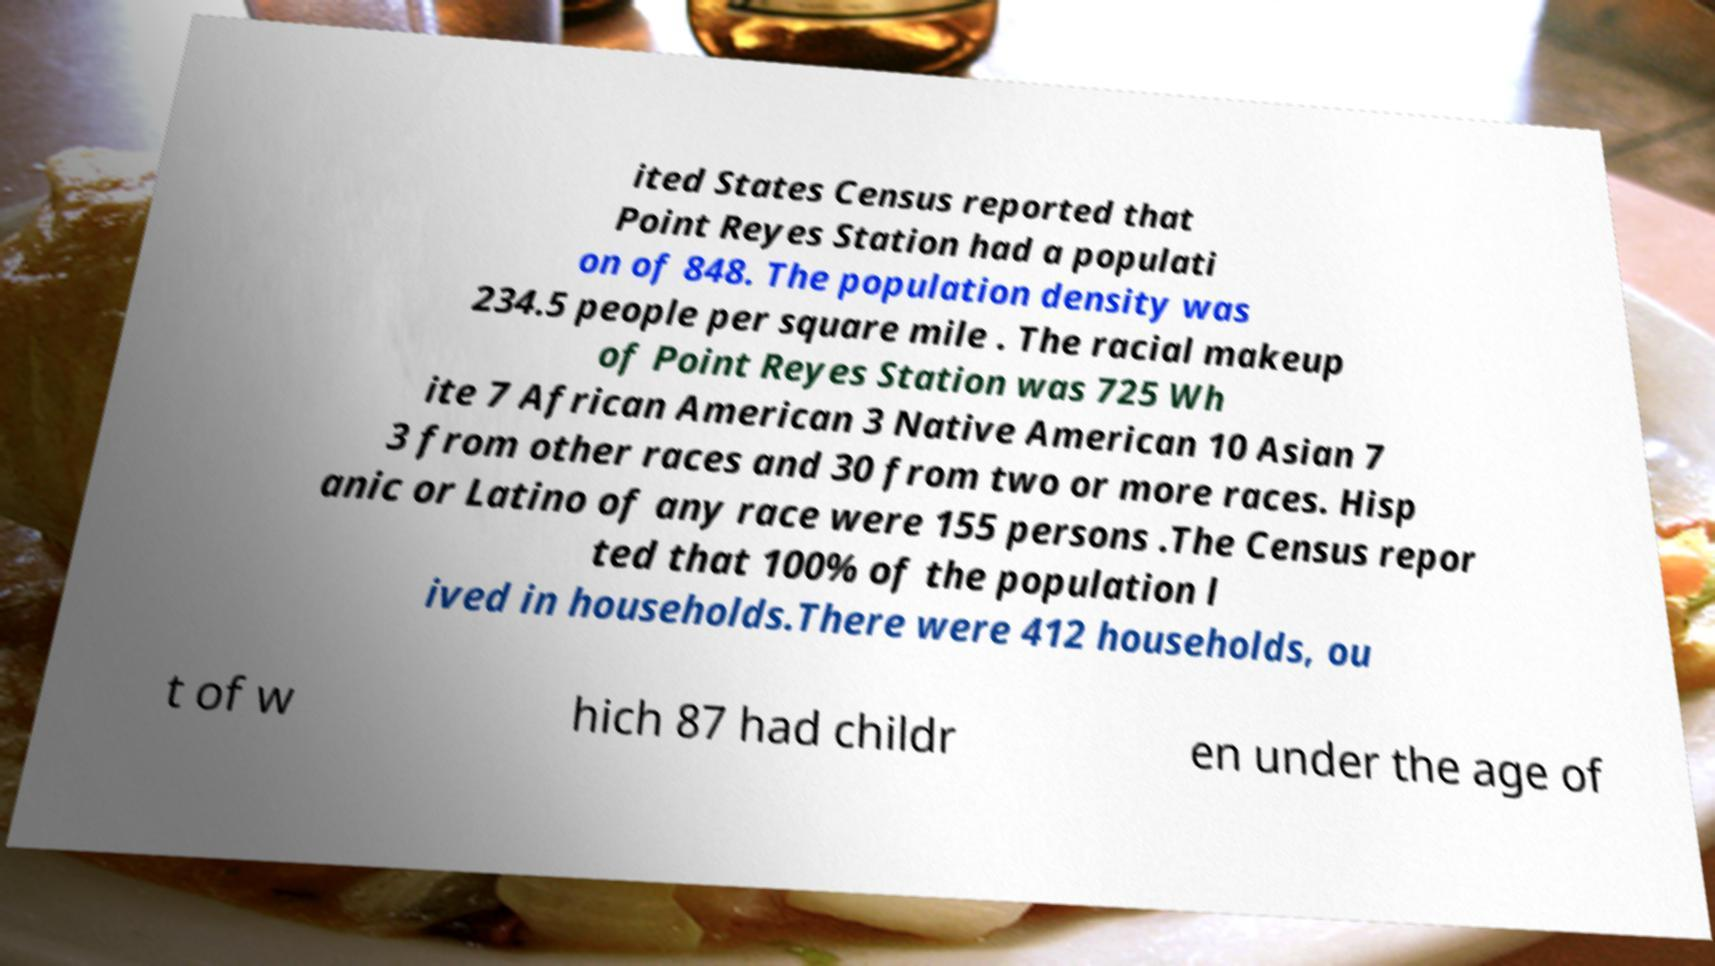There's text embedded in this image that I need extracted. Can you transcribe it verbatim? ited States Census reported that Point Reyes Station had a populati on of 848. The population density was 234.5 people per square mile . The racial makeup of Point Reyes Station was 725 Wh ite 7 African American 3 Native American 10 Asian 7 3 from other races and 30 from two or more races. Hisp anic or Latino of any race were 155 persons .The Census repor ted that 100% of the population l ived in households.There were 412 households, ou t of w hich 87 had childr en under the age of 